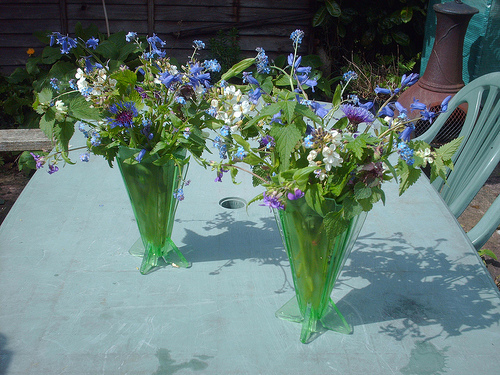Please provide a short description for this region: [0.21, 0.32, 0.29, 0.38]. A cluster of delicate blue flowers with a hint of purple, nestled among green foliage, is situated in this region of the image. 